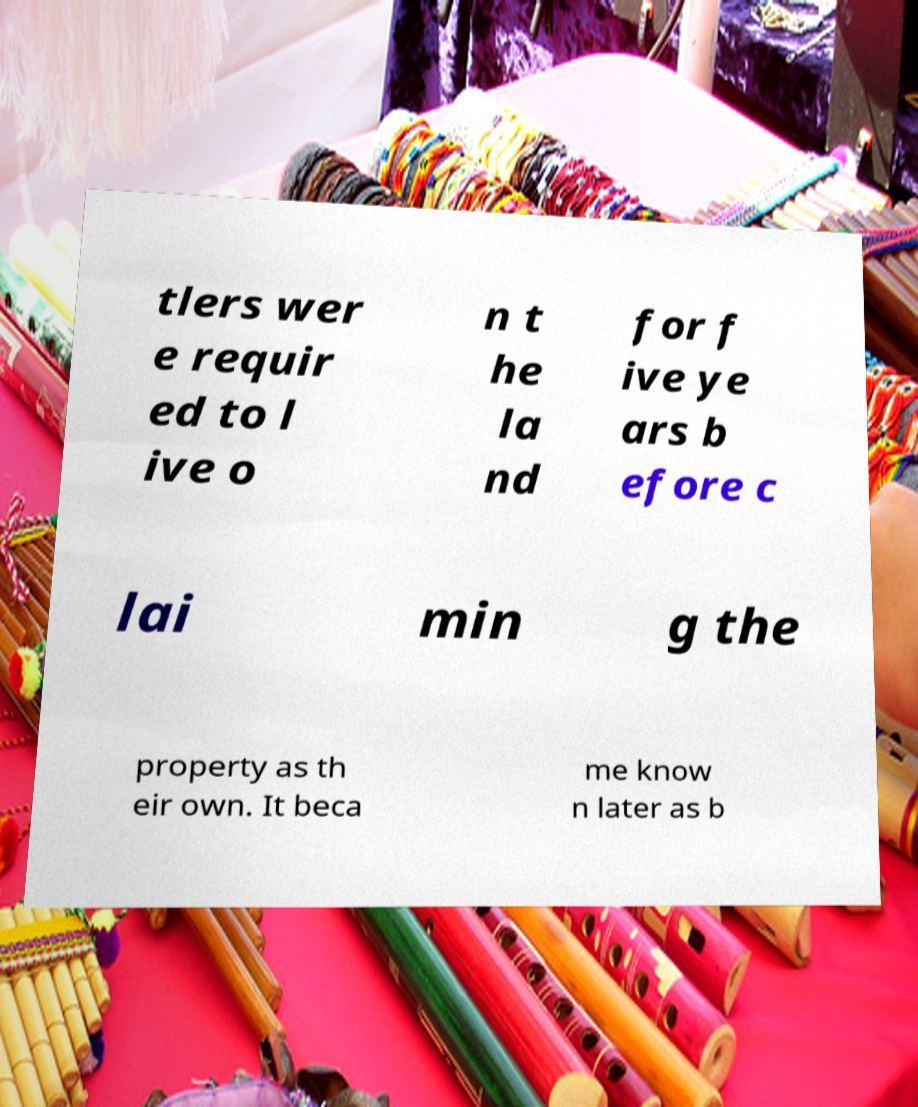What messages or text are displayed in this image? I need them in a readable, typed format. tlers wer e requir ed to l ive o n t he la nd for f ive ye ars b efore c lai min g the property as th eir own. It beca me know n later as b 